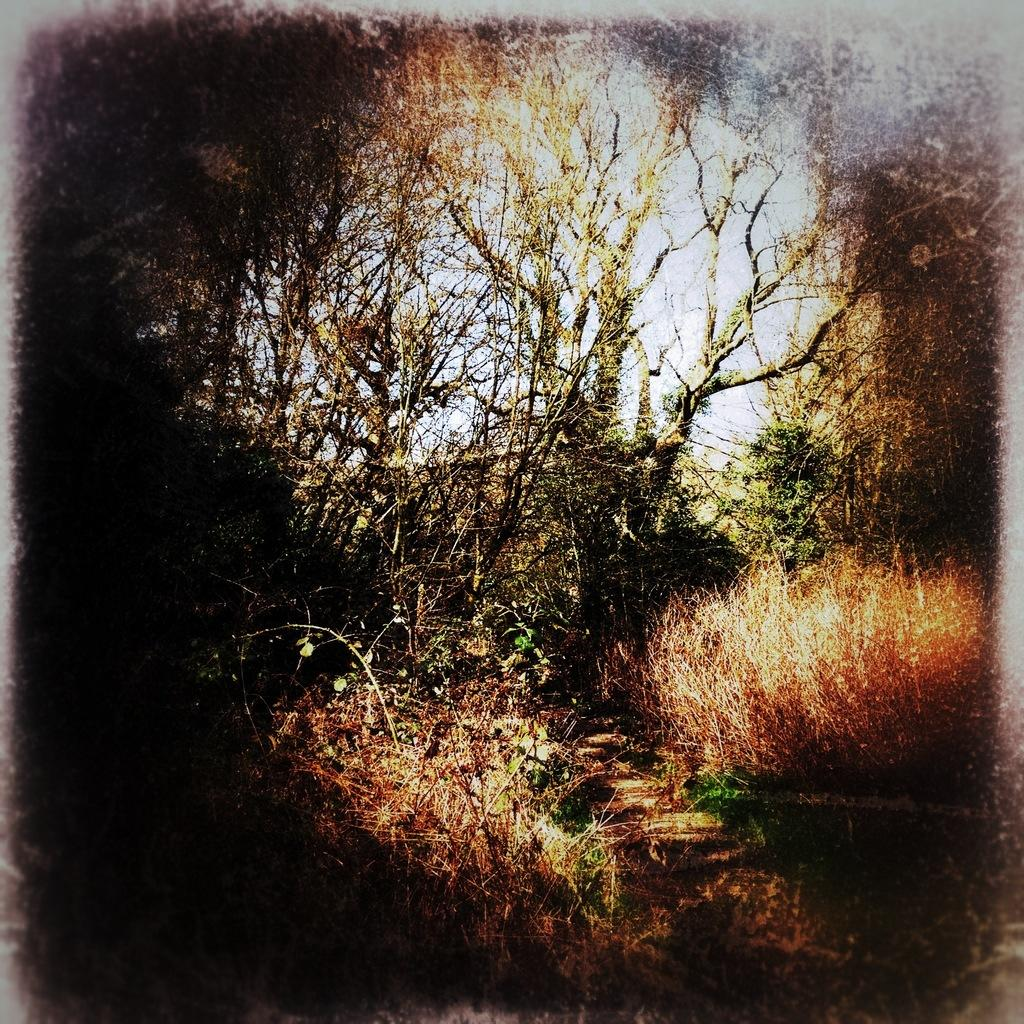What can be observed about the image's appearance? The image appears to be edited. What type of vegetation is present in the image? There is dried grass in the image. What other natural elements can be seen in the image? There are trees with branches and leaves in the image. What type of corn is growing in the image? There is no corn present in the image; it features dried grass and trees. Can you tell me how many ministers are visible in the image? There are no ministers present in the image. 